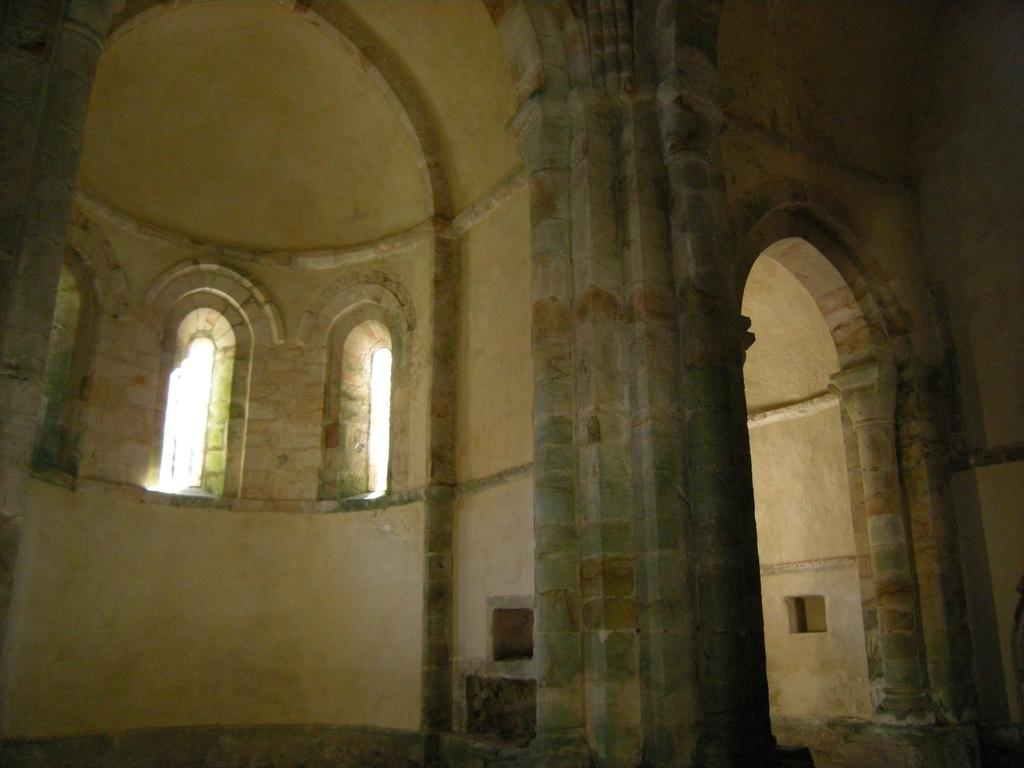What architectural features can be seen in the image? There are pillars and walls in the image. Where are the windows located in the image? The windows are on the left side of the image. What type of structure might the image depict? The image appears to depict the inside part of a fort. How many pizzas are being delivered to the fort in the image? There is no indication of any pizzas or deliveries in the image; it only depicts the interior of a fort with pillars, walls, and windows. 